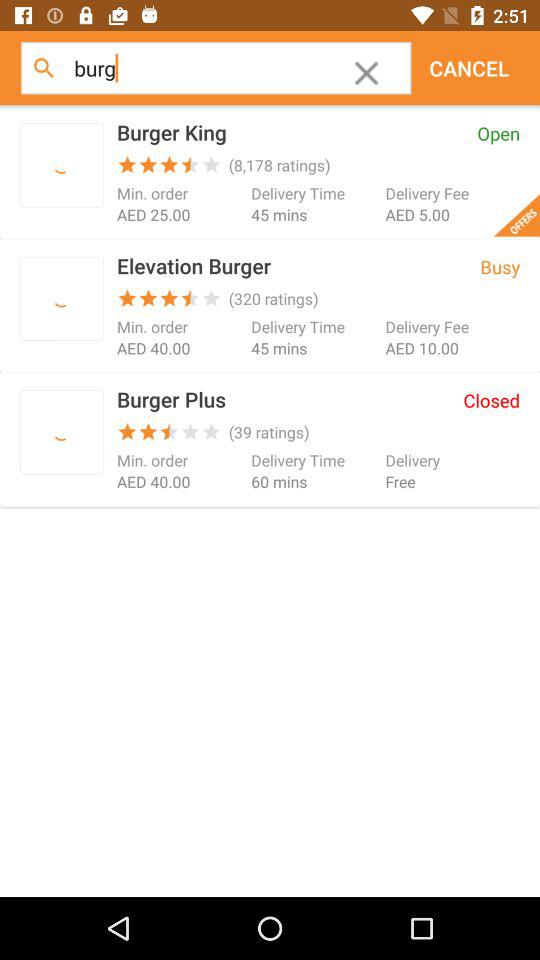Which restaurant has the most ratings?
Answer the question using a single word or phrase. Burger King 